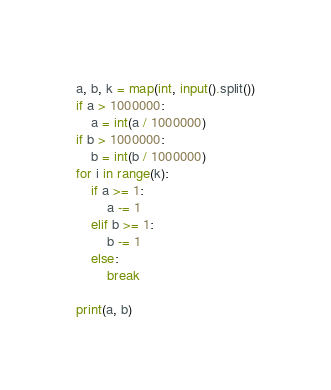<code> <loc_0><loc_0><loc_500><loc_500><_Python_>a, b, k = map(int, input().split())
if a > 1000000:
    a = int(a / 1000000)
if b > 1000000:
    b = int(b / 1000000)
for i in range(k):
    if a >= 1:
        a -= 1
    elif b >= 1:
        b -= 1
    else:
        break

print(a, b)</code> 